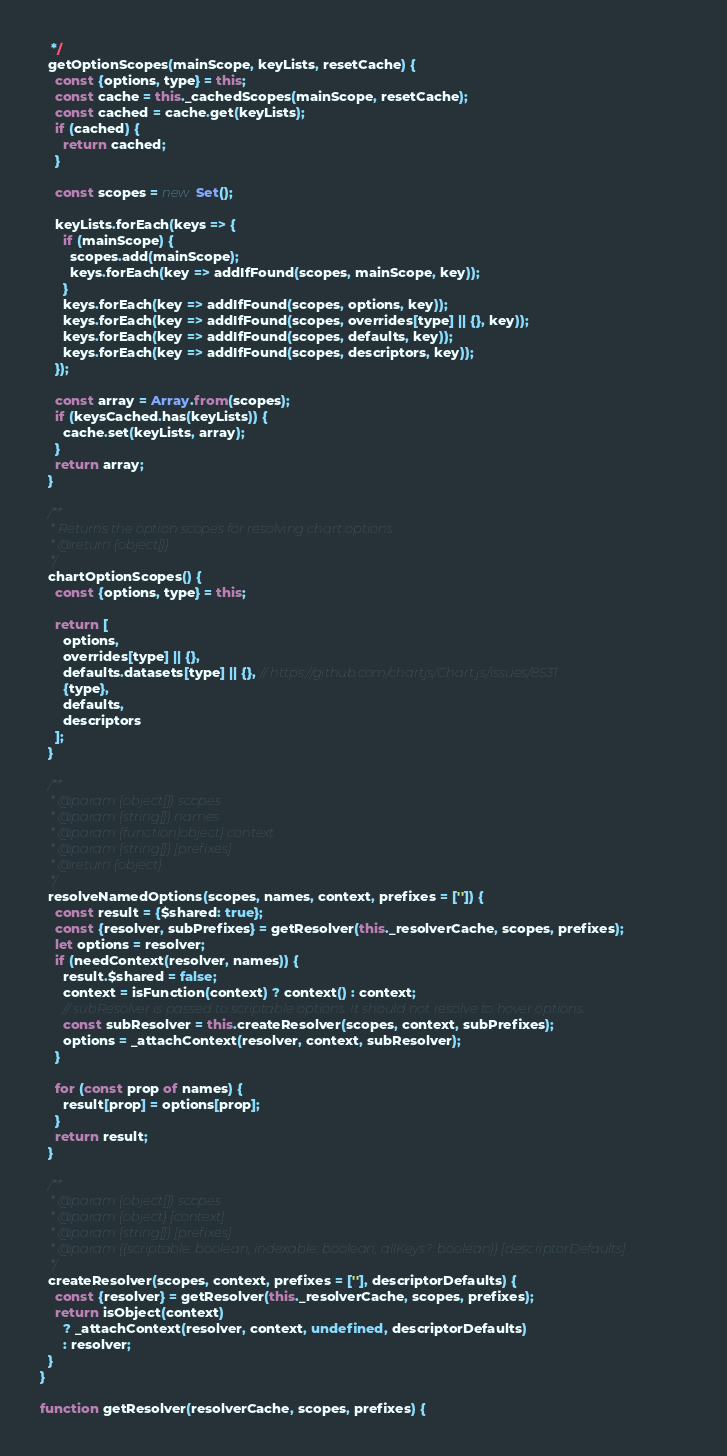Convert code to text. <code><loc_0><loc_0><loc_500><loc_500><_JavaScript_>   */
  getOptionScopes(mainScope, keyLists, resetCache) {
    const {options, type} = this;
    const cache = this._cachedScopes(mainScope, resetCache);
    const cached = cache.get(keyLists);
    if (cached) {
      return cached;
    }

    const scopes = new Set();

    keyLists.forEach(keys => {
      if (mainScope) {
        scopes.add(mainScope);
        keys.forEach(key => addIfFound(scopes, mainScope, key));
      }
      keys.forEach(key => addIfFound(scopes, options, key));
      keys.forEach(key => addIfFound(scopes, overrides[type] || {}, key));
      keys.forEach(key => addIfFound(scopes, defaults, key));
      keys.forEach(key => addIfFound(scopes, descriptors, key));
    });

    const array = Array.from(scopes);
    if (keysCached.has(keyLists)) {
      cache.set(keyLists, array);
    }
    return array;
  }

  /**
   * Returns the option scopes for resolving chart options
   * @return {object[]}
   */
  chartOptionScopes() {
    const {options, type} = this;

    return [
      options,
      overrides[type] || {},
      defaults.datasets[type] || {}, // https://github.com/chartjs/Chart.js/issues/8531
      {type},
      defaults,
      descriptors
    ];
  }

  /**
   * @param {object[]} scopes
   * @param {string[]} names
   * @param {function|object} context
   * @param {string[]} [prefixes]
   * @return {object}
   */
  resolveNamedOptions(scopes, names, context, prefixes = ['']) {
    const result = {$shared: true};
    const {resolver, subPrefixes} = getResolver(this._resolverCache, scopes, prefixes);
    let options = resolver;
    if (needContext(resolver, names)) {
      result.$shared = false;
      context = isFunction(context) ? context() : context;
      // subResolver is passed to scriptable options. It should not resolve to hover options.
      const subResolver = this.createResolver(scopes, context, subPrefixes);
      options = _attachContext(resolver, context, subResolver);
    }

    for (const prop of names) {
      result[prop] = options[prop];
    }
    return result;
  }

  /**
   * @param {object[]} scopes
   * @param {object} [context]
   * @param {string[]} [prefixes]
   * @param {{scriptable: boolean, indexable: boolean, allKeys?: boolean}} [descriptorDefaults]
   */
  createResolver(scopes, context, prefixes = [''], descriptorDefaults) {
    const {resolver} = getResolver(this._resolverCache, scopes, prefixes);
    return isObject(context)
      ? _attachContext(resolver, context, undefined, descriptorDefaults)
      : resolver;
  }
}

function getResolver(resolverCache, scopes, prefixes) {</code> 